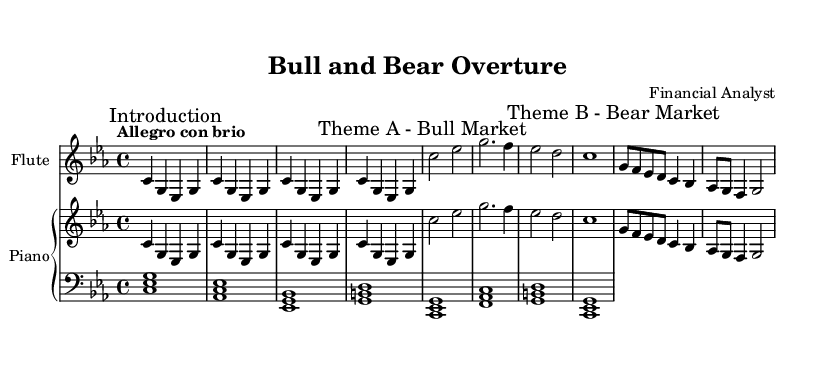What is the key signature of this music? The key signature is indicated at the beginning of the staff. It shows three flats (B, E, and A), which is characteristic of C minor.
Answer: C minor What is the time signature of the composition? The time signature is located at the beginning of the score indicated as 4/4, signifying four beats per measure.
Answer: 4/4 What is the tempo marking for the piece? The tempo marking describes the intended speed of the piece, which is written as "Allegro con brio," indicating a lively and spirited pace.
Answer: Allegro con brio How many distinct themes are present in the score? Upon examining the sections marked, there are two distinct themes labeled as Theme A (Bull Market) and Theme B (Bear Market).
Answer: Two What instruments are featured in this composition? The instruments are specified in the score layout. The two primary instrument sections are Flute and Piano, with the piano having two staves (treble and bass).
Answer: Flute and Piano What does "Theme A" represent in this symphony? The markings on the score note this part as "Theme A - Bull Market," indicating that this theme represents a positive market condition.
Answer: Bull Market What character does "Theme B" evoke in the context of the piece? The label "Theme B - Bear Market," illustrates that this theme reflects a downturn, typical of a bear market scenario in finance.
Answer: Bear Market 